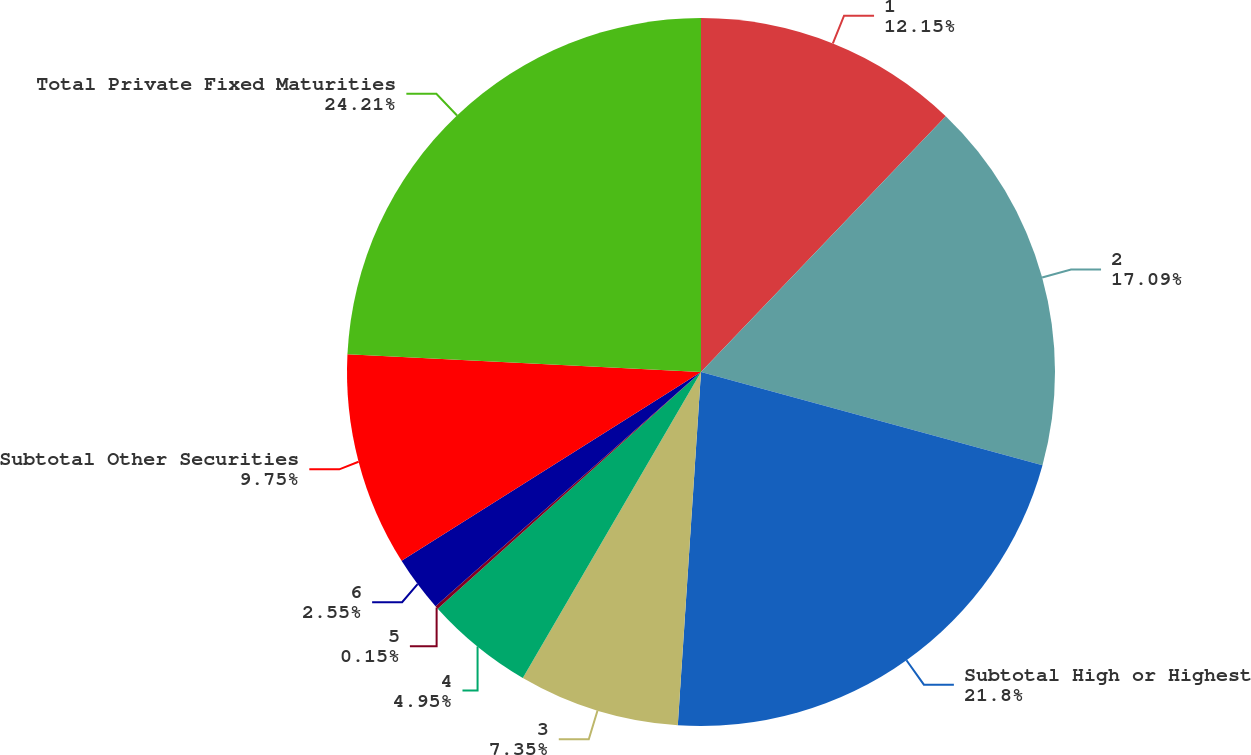Convert chart to OTSL. <chart><loc_0><loc_0><loc_500><loc_500><pie_chart><fcel>1<fcel>2<fcel>Subtotal High or Highest<fcel>3<fcel>4<fcel>5<fcel>6<fcel>Subtotal Other Securities<fcel>Total Private Fixed Maturities<nl><fcel>12.15%<fcel>17.09%<fcel>21.8%<fcel>7.35%<fcel>4.95%<fcel>0.15%<fcel>2.55%<fcel>9.75%<fcel>24.2%<nl></chart> 